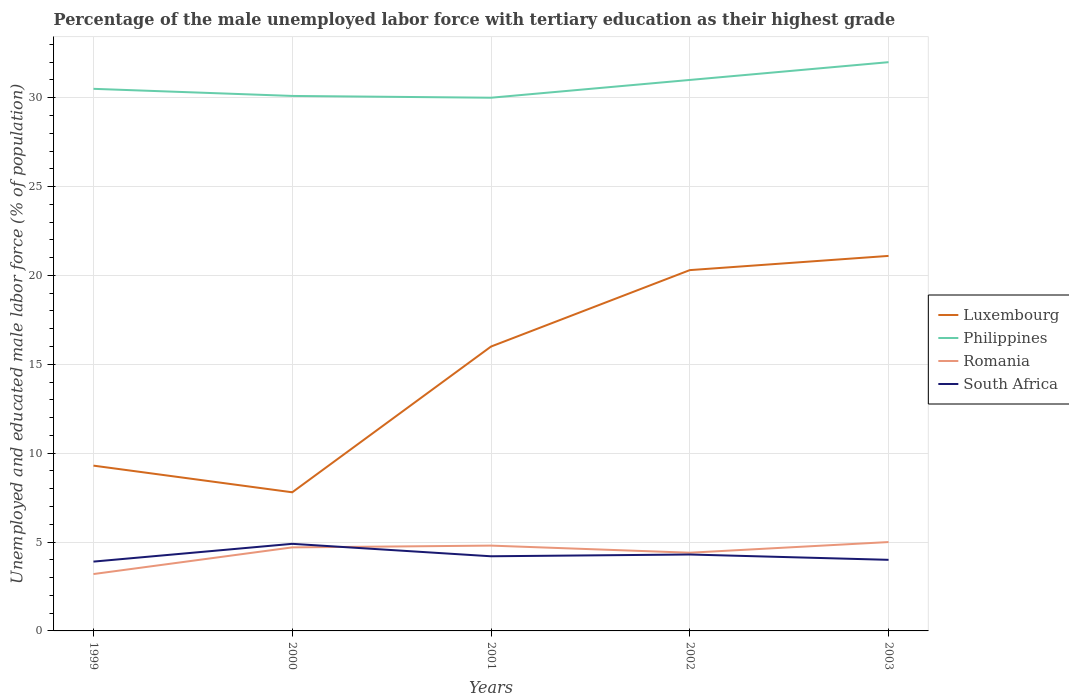How many different coloured lines are there?
Ensure brevity in your answer.  4. Does the line corresponding to Luxembourg intersect with the line corresponding to South Africa?
Provide a succinct answer. No. Is the number of lines equal to the number of legend labels?
Your response must be concise. Yes. Across all years, what is the maximum percentage of the unemployed male labor force with tertiary education in Luxembourg?
Provide a succinct answer. 7.8. In which year was the percentage of the unemployed male labor force with tertiary education in Romania maximum?
Provide a succinct answer. 1999. What is the total percentage of the unemployed male labor force with tertiary education in Romania in the graph?
Offer a very short reply. -1.5. What is the difference between the highest and the second highest percentage of the unemployed male labor force with tertiary education in South Africa?
Offer a terse response. 1. What is the difference between the highest and the lowest percentage of the unemployed male labor force with tertiary education in Romania?
Ensure brevity in your answer.  3. How many lines are there?
Offer a terse response. 4. What is the difference between two consecutive major ticks on the Y-axis?
Your answer should be very brief. 5. Are the values on the major ticks of Y-axis written in scientific E-notation?
Ensure brevity in your answer.  No. Does the graph contain any zero values?
Give a very brief answer. No. Does the graph contain grids?
Offer a very short reply. Yes. Where does the legend appear in the graph?
Provide a succinct answer. Center right. What is the title of the graph?
Offer a terse response. Percentage of the male unemployed labor force with tertiary education as their highest grade. What is the label or title of the X-axis?
Give a very brief answer. Years. What is the label or title of the Y-axis?
Ensure brevity in your answer.  Unemployed and educated male labor force (% of population). What is the Unemployed and educated male labor force (% of population) in Luxembourg in 1999?
Your answer should be compact. 9.3. What is the Unemployed and educated male labor force (% of population) in Philippines in 1999?
Offer a very short reply. 30.5. What is the Unemployed and educated male labor force (% of population) in Romania in 1999?
Your answer should be very brief. 3.2. What is the Unemployed and educated male labor force (% of population) in South Africa in 1999?
Your answer should be very brief. 3.9. What is the Unemployed and educated male labor force (% of population) of Luxembourg in 2000?
Make the answer very short. 7.8. What is the Unemployed and educated male labor force (% of population) in Philippines in 2000?
Offer a terse response. 30.1. What is the Unemployed and educated male labor force (% of population) in Romania in 2000?
Make the answer very short. 4.7. What is the Unemployed and educated male labor force (% of population) of South Africa in 2000?
Your answer should be very brief. 4.9. What is the Unemployed and educated male labor force (% of population) in Luxembourg in 2001?
Provide a short and direct response. 16. What is the Unemployed and educated male labor force (% of population) of Romania in 2001?
Provide a short and direct response. 4.8. What is the Unemployed and educated male labor force (% of population) in South Africa in 2001?
Your response must be concise. 4.2. What is the Unemployed and educated male labor force (% of population) of Luxembourg in 2002?
Offer a very short reply. 20.3. What is the Unemployed and educated male labor force (% of population) in Romania in 2002?
Your answer should be very brief. 4.4. What is the Unemployed and educated male labor force (% of population) of South Africa in 2002?
Provide a succinct answer. 4.3. What is the Unemployed and educated male labor force (% of population) of Luxembourg in 2003?
Provide a short and direct response. 21.1. What is the Unemployed and educated male labor force (% of population) in Romania in 2003?
Offer a terse response. 5. What is the Unemployed and educated male labor force (% of population) in South Africa in 2003?
Your answer should be very brief. 4. Across all years, what is the maximum Unemployed and educated male labor force (% of population) of Luxembourg?
Your answer should be very brief. 21.1. Across all years, what is the maximum Unemployed and educated male labor force (% of population) in Philippines?
Your answer should be compact. 32. Across all years, what is the maximum Unemployed and educated male labor force (% of population) in Romania?
Your answer should be compact. 5. Across all years, what is the maximum Unemployed and educated male labor force (% of population) in South Africa?
Give a very brief answer. 4.9. Across all years, what is the minimum Unemployed and educated male labor force (% of population) in Luxembourg?
Your answer should be compact. 7.8. Across all years, what is the minimum Unemployed and educated male labor force (% of population) in Romania?
Provide a succinct answer. 3.2. Across all years, what is the minimum Unemployed and educated male labor force (% of population) of South Africa?
Give a very brief answer. 3.9. What is the total Unemployed and educated male labor force (% of population) of Luxembourg in the graph?
Offer a terse response. 74.5. What is the total Unemployed and educated male labor force (% of population) of Philippines in the graph?
Your answer should be compact. 153.6. What is the total Unemployed and educated male labor force (% of population) of Romania in the graph?
Your answer should be compact. 22.1. What is the total Unemployed and educated male labor force (% of population) of South Africa in the graph?
Provide a short and direct response. 21.3. What is the difference between the Unemployed and educated male labor force (% of population) in Luxembourg in 1999 and that in 2000?
Offer a very short reply. 1.5. What is the difference between the Unemployed and educated male labor force (% of population) in Philippines in 1999 and that in 2000?
Provide a succinct answer. 0.4. What is the difference between the Unemployed and educated male labor force (% of population) in South Africa in 1999 and that in 2000?
Ensure brevity in your answer.  -1. What is the difference between the Unemployed and educated male labor force (% of population) of Luxembourg in 1999 and that in 2001?
Keep it short and to the point. -6.7. What is the difference between the Unemployed and educated male labor force (% of population) of Romania in 1999 and that in 2001?
Provide a short and direct response. -1.6. What is the difference between the Unemployed and educated male labor force (% of population) in South Africa in 1999 and that in 2001?
Ensure brevity in your answer.  -0.3. What is the difference between the Unemployed and educated male labor force (% of population) in Philippines in 1999 and that in 2002?
Make the answer very short. -0.5. What is the difference between the Unemployed and educated male labor force (% of population) in South Africa in 1999 and that in 2002?
Make the answer very short. -0.4. What is the difference between the Unemployed and educated male labor force (% of population) of Luxembourg in 1999 and that in 2003?
Make the answer very short. -11.8. What is the difference between the Unemployed and educated male labor force (% of population) of Philippines in 1999 and that in 2003?
Make the answer very short. -1.5. What is the difference between the Unemployed and educated male labor force (% of population) in South Africa in 1999 and that in 2003?
Your answer should be very brief. -0.1. What is the difference between the Unemployed and educated male labor force (% of population) of Luxembourg in 2000 and that in 2001?
Provide a succinct answer. -8.2. What is the difference between the Unemployed and educated male labor force (% of population) of South Africa in 2000 and that in 2001?
Provide a short and direct response. 0.7. What is the difference between the Unemployed and educated male labor force (% of population) in Romania in 2000 and that in 2002?
Ensure brevity in your answer.  0.3. What is the difference between the Unemployed and educated male labor force (% of population) in Luxembourg in 2000 and that in 2003?
Offer a very short reply. -13.3. What is the difference between the Unemployed and educated male labor force (% of population) of Luxembourg in 2001 and that in 2002?
Your answer should be very brief. -4.3. What is the difference between the Unemployed and educated male labor force (% of population) of Romania in 2001 and that in 2002?
Provide a short and direct response. 0.4. What is the difference between the Unemployed and educated male labor force (% of population) of South Africa in 2001 and that in 2002?
Make the answer very short. -0.1. What is the difference between the Unemployed and educated male labor force (% of population) in Luxembourg in 2001 and that in 2003?
Ensure brevity in your answer.  -5.1. What is the difference between the Unemployed and educated male labor force (% of population) of South Africa in 2002 and that in 2003?
Ensure brevity in your answer.  0.3. What is the difference between the Unemployed and educated male labor force (% of population) of Luxembourg in 1999 and the Unemployed and educated male labor force (% of population) of Philippines in 2000?
Provide a short and direct response. -20.8. What is the difference between the Unemployed and educated male labor force (% of population) in Luxembourg in 1999 and the Unemployed and educated male labor force (% of population) in South Africa in 2000?
Keep it short and to the point. 4.4. What is the difference between the Unemployed and educated male labor force (% of population) in Philippines in 1999 and the Unemployed and educated male labor force (% of population) in Romania in 2000?
Offer a very short reply. 25.8. What is the difference between the Unemployed and educated male labor force (% of population) in Philippines in 1999 and the Unemployed and educated male labor force (% of population) in South Africa in 2000?
Your answer should be compact. 25.6. What is the difference between the Unemployed and educated male labor force (% of population) in Romania in 1999 and the Unemployed and educated male labor force (% of population) in South Africa in 2000?
Ensure brevity in your answer.  -1.7. What is the difference between the Unemployed and educated male labor force (% of population) in Luxembourg in 1999 and the Unemployed and educated male labor force (% of population) in Philippines in 2001?
Your answer should be very brief. -20.7. What is the difference between the Unemployed and educated male labor force (% of population) in Luxembourg in 1999 and the Unemployed and educated male labor force (% of population) in Romania in 2001?
Make the answer very short. 4.5. What is the difference between the Unemployed and educated male labor force (% of population) in Luxembourg in 1999 and the Unemployed and educated male labor force (% of population) in South Africa in 2001?
Provide a succinct answer. 5.1. What is the difference between the Unemployed and educated male labor force (% of population) of Philippines in 1999 and the Unemployed and educated male labor force (% of population) of Romania in 2001?
Your response must be concise. 25.7. What is the difference between the Unemployed and educated male labor force (% of population) of Philippines in 1999 and the Unemployed and educated male labor force (% of population) of South Africa in 2001?
Make the answer very short. 26.3. What is the difference between the Unemployed and educated male labor force (% of population) of Romania in 1999 and the Unemployed and educated male labor force (% of population) of South Africa in 2001?
Give a very brief answer. -1. What is the difference between the Unemployed and educated male labor force (% of population) in Luxembourg in 1999 and the Unemployed and educated male labor force (% of population) in Philippines in 2002?
Offer a very short reply. -21.7. What is the difference between the Unemployed and educated male labor force (% of population) in Luxembourg in 1999 and the Unemployed and educated male labor force (% of population) in Romania in 2002?
Ensure brevity in your answer.  4.9. What is the difference between the Unemployed and educated male labor force (% of population) of Luxembourg in 1999 and the Unemployed and educated male labor force (% of population) of South Africa in 2002?
Ensure brevity in your answer.  5. What is the difference between the Unemployed and educated male labor force (% of population) of Philippines in 1999 and the Unemployed and educated male labor force (% of population) of Romania in 2002?
Offer a terse response. 26.1. What is the difference between the Unemployed and educated male labor force (% of population) in Philippines in 1999 and the Unemployed and educated male labor force (% of population) in South Africa in 2002?
Your answer should be very brief. 26.2. What is the difference between the Unemployed and educated male labor force (% of population) in Romania in 1999 and the Unemployed and educated male labor force (% of population) in South Africa in 2002?
Provide a succinct answer. -1.1. What is the difference between the Unemployed and educated male labor force (% of population) in Luxembourg in 1999 and the Unemployed and educated male labor force (% of population) in Philippines in 2003?
Offer a very short reply. -22.7. What is the difference between the Unemployed and educated male labor force (% of population) of Philippines in 1999 and the Unemployed and educated male labor force (% of population) of Romania in 2003?
Ensure brevity in your answer.  25.5. What is the difference between the Unemployed and educated male labor force (% of population) in Luxembourg in 2000 and the Unemployed and educated male labor force (% of population) in Philippines in 2001?
Give a very brief answer. -22.2. What is the difference between the Unemployed and educated male labor force (% of population) in Philippines in 2000 and the Unemployed and educated male labor force (% of population) in Romania in 2001?
Your response must be concise. 25.3. What is the difference between the Unemployed and educated male labor force (% of population) of Philippines in 2000 and the Unemployed and educated male labor force (% of population) of South Africa in 2001?
Offer a terse response. 25.9. What is the difference between the Unemployed and educated male labor force (% of population) of Romania in 2000 and the Unemployed and educated male labor force (% of population) of South Africa in 2001?
Ensure brevity in your answer.  0.5. What is the difference between the Unemployed and educated male labor force (% of population) of Luxembourg in 2000 and the Unemployed and educated male labor force (% of population) of Philippines in 2002?
Keep it short and to the point. -23.2. What is the difference between the Unemployed and educated male labor force (% of population) in Philippines in 2000 and the Unemployed and educated male labor force (% of population) in Romania in 2002?
Give a very brief answer. 25.7. What is the difference between the Unemployed and educated male labor force (% of population) of Philippines in 2000 and the Unemployed and educated male labor force (% of population) of South Africa in 2002?
Provide a succinct answer. 25.8. What is the difference between the Unemployed and educated male labor force (% of population) of Luxembourg in 2000 and the Unemployed and educated male labor force (% of population) of Philippines in 2003?
Your answer should be very brief. -24.2. What is the difference between the Unemployed and educated male labor force (% of population) of Luxembourg in 2000 and the Unemployed and educated male labor force (% of population) of South Africa in 2003?
Your answer should be compact. 3.8. What is the difference between the Unemployed and educated male labor force (% of population) in Philippines in 2000 and the Unemployed and educated male labor force (% of population) in Romania in 2003?
Your response must be concise. 25.1. What is the difference between the Unemployed and educated male labor force (% of population) of Philippines in 2000 and the Unemployed and educated male labor force (% of population) of South Africa in 2003?
Offer a terse response. 26.1. What is the difference between the Unemployed and educated male labor force (% of population) in Romania in 2000 and the Unemployed and educated male labor force (% of population) in South Africa in 2003?
Ensure brevity in your answer.  0.7. What is the difference between the Unemployed and educated male labor force (% of population) of Luxembourg in 2001 and the Unemployed and educated male labor force (% of population) of Philippines in 2002?
Give a very brief answer. -15. What is the difference between the Unemployed and educated male labor force (% of population) of Luxembourg in 2001 and the Unemployed and educated male labor force (% of population) of South Africa in 2002?
Your answer should be very brief. 11.7. What is the difference between the Unemployed and educated male labor force (% of population) of Philippines in 2001 and the Unemployed and educated male labor force (% of population) of Romania in 2002?
Provide a succinct answer. 25.6. What is the difference between the Unemployed and educated male labor force (% of population) of Philippines in 2001 and the Unemployed and educated male labor force (% of population) of South Africa in 2002?
Give a very brief answer. 25.7. What is the difference between the Unemployed and educated male labor force (% of population) of Luxembourg in 2001 and the Unemployed and educated male labor force (% of population) of Romania in 2003?
Your answer should be compact. 11. What is the difference between the Unemployed and educated male labor force (% of population) of Luxembourg in 2001 and the Unemployed and educated male labor force (% of population) of South Africa in 2003?
Provide a succinct answer. 12. What is the difference between the Unemployed and educated male labor force (% of population) of Philippines in 2001 and the Unemployed and educated male labor force (% of population) of South Africa in 2003?
Your answer should be very brief. 26. What is the difference between the Unemployed and educated male labor force (% of population) in Luxembourg in 2002 and the Unemployed and educated male labor force (% of population) in Philippines in 2003?
Ensure brevity in your answer.  -11.7. What is the difference between the Unemployed and educated male labor force (% of population) of Luxembourg in 2002 and the Unemployed and educated male labor force (% of population) of Romania in 2003?
Keep it short and to the point. 15.3. What is the difference between the Unemployed and educated male labor force (% of population) in Luxembourg in 2002 and the Unemployed and educated male labor force (% of population) in South Africa in 2003?
Make the answer very short. 16.3. What is the difference between the Unemployed and educated male labor force (% of population) of Philippines in 2002 and the Unemployed and educated male labor force (% of population) of Romania in 2003?
Offer a very short reply. 26. What is the difference between the Unemployed and educated male labor force (% of population) in Philippines in 2002 and the Unemployed and educated male labor force (% of population) in South Africa in 2003?
Make the answer very short. 27. What is the difference between the Unemployed and educated male labor force (% of population) of Romania in 2002 and the Unemployed and educated male labor force (% of population) of South Africa in 2003?
Provide a short and direct response. 0.4. What is the average Unemployed and educated male labor force (% of population) in Luxembourg per year?
Offer a terse response. 14.9. What is the average Unemployed and educated male labor force (% of population) of Philippines per year?
Your response must be concise. 30.72. What is the average Unemployed and educated male labor force (% of population) in Romania per year?
Make the answer very short. 4.42. What is the average Unemployed and educated male labor force (% of population) in South Africa per year?
Offer a very short reply. 4.26. In the year 1999, what is the difference between the Unemployed and educated male labor force (% of population) in Luxembourg and Unemployed and educated male labor force (% of population) in Philippines?
Give a very brief answer. -21.2. In the year 1999, what is the difference between the Unemployed and educated male labor force (% of population) in Philippines and Unemployed and educated male labor force (% of population) in Romania?
Provide a succinct answer. 27.3. In the year 1999, what is the difference between the Unemployed and educated male labor force (% of population) in Philippines and Unemployed and educated male labor force (% of population) in South Africa?
Your answer should be very brief. 26.6. In the year 2000, what is the difference between the Unemployed and educated male labor force (% of population) of Luxembourg and Unemployed and educated male labor force (% of population) of Philippines?
Provide a succinct answer. -22.3. In the year 2000, what is the difference between the Unemployed and educated male labor force (% of population) in Luxembourg and Unemployed and educated male labor force (% of population) in Romania?
Your response must be concise. 3.1. In the year 2000, what is the difference between the Unemployed and educated male labor force (% of population) of Luxembourg and Unemployed and educated male labor force (% of population) of South Africa?
Provide a short and direct response. 2.9. In the year 2000, what is the difference between the Unemployed and educated male labor force (% of population) in Philippines and Unemployed and educated male labor force (% of population) in Romania?
Make the answer very short. 25.4. In the year 2000, what is the difference between the Unemployed and educated male labor force (% of population) in Philippines and Unemployed and educated male labor force (% of population) in South Africa?
Give a very brief answer. 25.2. In the year 2001, what is the difference between the Unemployed and educated male labor force (% of population) of Luxembourg and Unemployed and educated male labor force (% of population) of Philippines?
Make the answer very short. -14. In the year 2001, what is the difference between the Unemployed and educated male labor force (% of population) of Luxembourg and Unemployed and educated male labor force (% of population) of Romania?
Provide a succinct answer. 11.2. In the year 2001, what is the difference between the Unemployed and educated male labor force (% of population) of Luxembourg and Unemployed and educated male labor force (% of population) of South Africa?
Offer a terse response. 11.8. In the year 2001, what is the difference between the Unemployed and educated male labor force (% of population) in Philippines and Unemployed and educated male labor force (% of population) in Romania?
Offer a very short reply. 25.2. In the year 2001, what is the difference between the Unemployed and educated male labor force (% of population) in Philippines and Unemployed and educated male labor force (% of population) in South Africa?
Your response must be concise. 25.8. In the year 2001, what is the difference between the Unemployed and educated male labor force (% of population) in Romania and Unemployed and educated male labor force (% of population) in South Africa?
Provide a succinct answer. 0.6. In the year 2002, what is the difference between the Unemployed and educated male labor force (% of population) of Luxembourg and Unemployed and educated male labor force (% of population) of Philippines?
Your answer should be very brief. -10.7. In the year 2002, what is the difference between the Unemployed and educated male labor force (% of population) in Luxembourg and Unemployed and educated male labor force (% of population) in Romania?
Your response must be concise. 15.9. In the year 2002, what is the difference between the Unemployed and educated male labor force (% of population) in Philippines and Unemployed and educated male labor force (% of population) in Romania?
Give a very brief answer. 26.6. In the year 2002, what is the difference between the Unemployed and educated male labor force (% of population) of Philippines and Unemployed and educated male labor force (% of population) of South Africa?
Provide a succinct answer. 26.7. In the year 2003, what is the difference between the Unemployed and educated male labor force (% of population) in Luxembourg and Unemployed and educated male labor force (% of population) in Philippines?
Provide a succinct answer. -10.9. In the year 2003, what is the difference between the Unemployed and educated male labor force (% of population) in Romania and Unemployed and educated male labor force (% of population) in South Africa?
Your answer should be very brief. 1. What is the ratio of the Unemployed and educated male labor force (% of population) in Luxembourg in 1999 to that in 2000?
Offer a terse response. 1.19. What is the ratio of the Unemployed and educated male labor force (% of population) of Philippines in 1999 to that in 2000?
Provide a short and direct response. 1.01. What is the ratio of the Unemployed and educated male labor force (% of population) of Romania in 1999 to that in 2000?
Provide a succinct answer. 0.68. What is the ratio of the Unemployed and educated male labor force (% of population) of South Africa in 1999 to that in 2000?
Offer a very short reply. 0.8. What is the ratio of the Unemployed and educated male labor force (% of population) of Luxembourg in 1999 to that in 2001?
Make the answer very short. 0.58. What is the ratio of the Unemployed and educated male labor force (% of population) of Philippines in 1999 to that in 2001?
Make the answer very short. 1.02. What is the ratio of the Unemployed and educated male labor force (% of population) in Luxembourg in 1999 to that in 2002?
Give a very brief answer. 0.46. What is the ratio of the Unemployed and educated male labor force (% of population) in Philippines in 1999 to that in 2002?
Keep it short and to the point. 0.98. What is the ratio of the Unemployed and educated male labor force (% of population) in Romania in 1999 to that in 2002?
Your response must be concise. 0.73. What is the ratio of the Unemployed and educated male labor force (% of population) of South Africa in 1999 to that in 2002?
Your answer should be very brief. 0.91. What is the ratio of the Unemployed and educated male labor force (% of population) in Luxembourg in 1999 to that in 2003?
Make the answer very short. 0.44. What is the ratio of the Unemployed and educated male labor force (% of population) of Philippines in 1999 to that in 2003?
Your answer should be compact. 0.95. What is the ratio of the Unemployed and educated male labor force (% of population) in Romania in 1999 to that in 2003?
Provide a short and direct response. 0.64. What is the ratio of the Unemployed and educated male labor force (% of population) in South Africa in 1999 to that in 2003?
Your answer should be very brief. 0.97. What is the ratio of the Unemployed and educated male labor force (% of population) of Luxembourg in 2000 to that in 2001?
Offer a very short reply. 0.49. What is the ratio of the Unemployed and educated male labor force (% of population) of Romania in 2000 to that in 2001?
Provide a succinct answer. 0.98. What is the ratio of the Unemployed and educated male labor force (% of population) in Luxembourg in 2000 to that in 2002?
Your answer should be compact. 0.38. What is the ratio of the Unemployed and educated male labor force (% of population) in Philippines in 2000 to that in 2002?
Ensure brevity in your answer.  0.97. What is the ratio of the Unemployed and educated male labor force (% of population) in Romania in 2000 to that in 2002?
Provide a succinct answer. 1.07. What is the ratio of the Unemployed and educated male labor force (% of population) in South Africa in 2000 to that in 2002?
Ensure brevity in your answer.  1.14. What is the ratio of the Unemployed and educated male labor force (% of population) of Luxembourg in 2000 to that in 2003?
Keep it short and to the point. 0.37. What is the ratio of the Unemployed and educated male labor force (% of population) in Philippines in 2000 to that in 2003?
Offer a terse response. 0.94. What is the ratio of the Unemployed and educated male labor force (% of population) in South Africa in 2000 to that in 2003?
Give a very brief answer. 1.23. What is the ratio of the Unemployed and educated male labor force (% of population) in Luxembourg in 2001 to that in 2002?
Ensure brevity in your answer.  0.79. What is the ratio of the Unemployed and educated male labor force (% of population) of Philippines in 2001 to that in 2002?
Your response must be concise. 0.97. What is the ratio of the Unemployed and educated male labor force (% of population) in South Africa in 2001 to that in 2002?
Offer a terse response. 0.98. What is the ratio of the Unemployed and educated male labor force (% of population) of Luxembourg in 2001 to that in 2003?
Offer a terse response. 0.76. What is the ratio of the Unemployed and educated male labor force (% of population) in Philippines in 2001 to that in 2003?
Provide a succinct answer. 0.94. What is the ratio of the Unemployed and educated male labor force (% of population) in Romania in 2001 to that in 2003?
Your answer should be compact. 0.96. What is the ratio of the Unemployed and educated male labor force (% of population) of South Africa in 2001 to that in 2003?
Give a very brief answer. 1.05. What is the ratio of the Unemployed and educated male labor force (% of population) of Luxembourg in 2002 to that in 2003?
Provide a succinct answer. 0.96. What is the ratio of the Unemployed and educated male labor force (% of population) of Philippines in 2002 to that in 2003?
Provide a short and direct response. 0.97. What is the ratio of the Unemployed and educated male labor force (% of population) of Romania in 2002 to that in 2003?
Give a very brief answer. 0.88. What is the ratio of the Unemployed and educated male labor force (% of population) of South Africa in 2002 to that in 2003?
Provide a short and direct response. 1.07. What is the difference between the highest and the second highest Unemployed and educated male labor force (% of population) in Luxembourg?
Offer a very short reply. 0.8. What is the difference between the highest and the second highest Unemployed and educated male labor force (% of population) in Romania?
Ensure brevity in your answer.  0.2. What is the difference between the highest and the second highest Unemployed and educated male labor force (% of population) of South Africa?
Your response must be concise. 0.6. What is the difference between the highest and the lowest Unemployed and educated male labor force (% of population) of South Africa?
Your response must be concise. 1. 